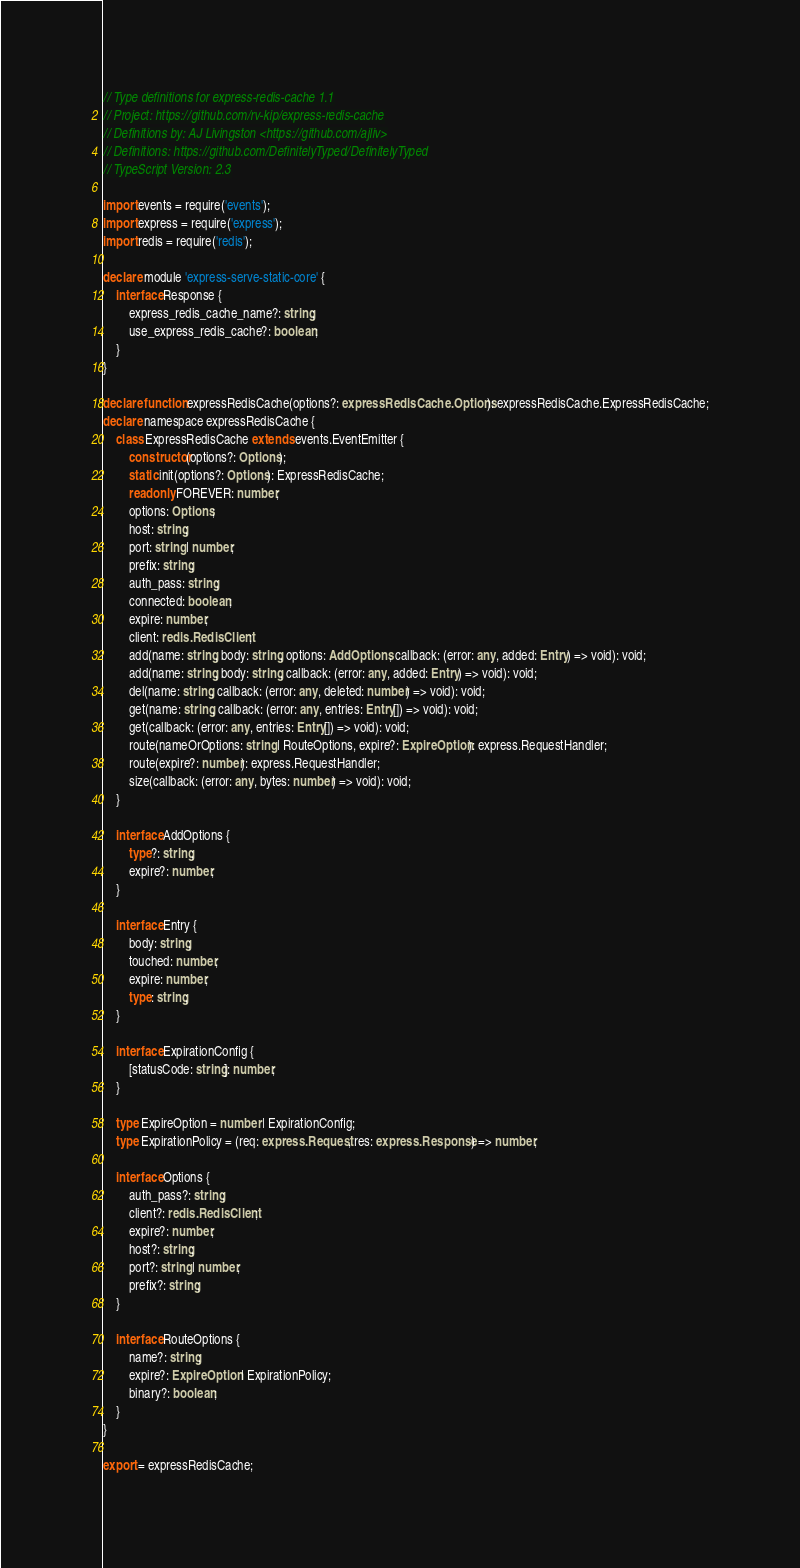<code> <loc_0><loc_0><loc_500><loc_500><_TypeScript_>// Type definitions for express-redis-cache 1.1
// Project: https://github.com/rv-kip/express-redis-cache
// Definitions by: AJ Livingston <https://github.com/ajliv>
// Definitions: https://github.com/DefinitelyTyped/DefinitelyTyped
// TypeScript Version: 2.3

import events = require('events');
import express = require('express');
import redis = require('redis');

declare module 'express-serve-static-core' {
    interface Response {
        express_redis_cache_name?: string;
        use_express_redis_cache?: boolean;
    }
}

declare function expressRedisCache(options?: expressRedisCache.Options): expressRedisCache.ExpressRedisCache;
declare namespace expressRedisCache {
    class ExpressRedisCache extends events.EventEmitter {
        constructor(options?: Options);
        static init(options?: Options): ExpressRedisCache;
        readonly FOREVER: number;
        options: Options;
        host: string;
        port: string | number;
        prefix: string;
        auth_pass: string;
        connected: boolean;
        expire: number;
        client: redis.RedisClient;
        add(name: string, body: string, options: AddOptions, callback: (error: any, added: Entry) => void): void;
        add(name: string, body: string, callback: (error: any, added: Entry) => void): void;
        del(name: string, callback: (error: any, deleted: number) => void): void;
        get(name: string, callback: (error: any, entries: Entry[]) => void): void;
        get(callback: (error: any, entries: Entry[]) => void): void;
        route(nameOrOptions: string | RouteOptions, expire?: ExpireOption): express.RequestHandler;
        route(expire?: number): express.RequestHandler;
        size(callback: (error: any, bytes: number) => void): void;
    }

    interface AddOptions {
        type?: string;
        expire?: number;
    }

    interface Entry {
        body: string;
        touched: number;
        expire: number;
        type: string;
    }

    interface ExpirationConfig {
        [statusCode: string]: number;
    }

    type ExpireOption = number | ExpirationConfig;
    type ExpirationPolicy = (req: express.Request, res: express.Response) => number;

    interface Options {
        auth_pass?: string;
        client?: redis.RedisClient;
        expire?: number;
        host?: string;
        port?: string | number;
        prefix?: string;
    }

    interface RouteOptions {
        name?: string;
        expire?: ExpireOption | ExpirationPolicy;
        binary?: boolean;
    }
}

export = expressRedisCache;
</code> 